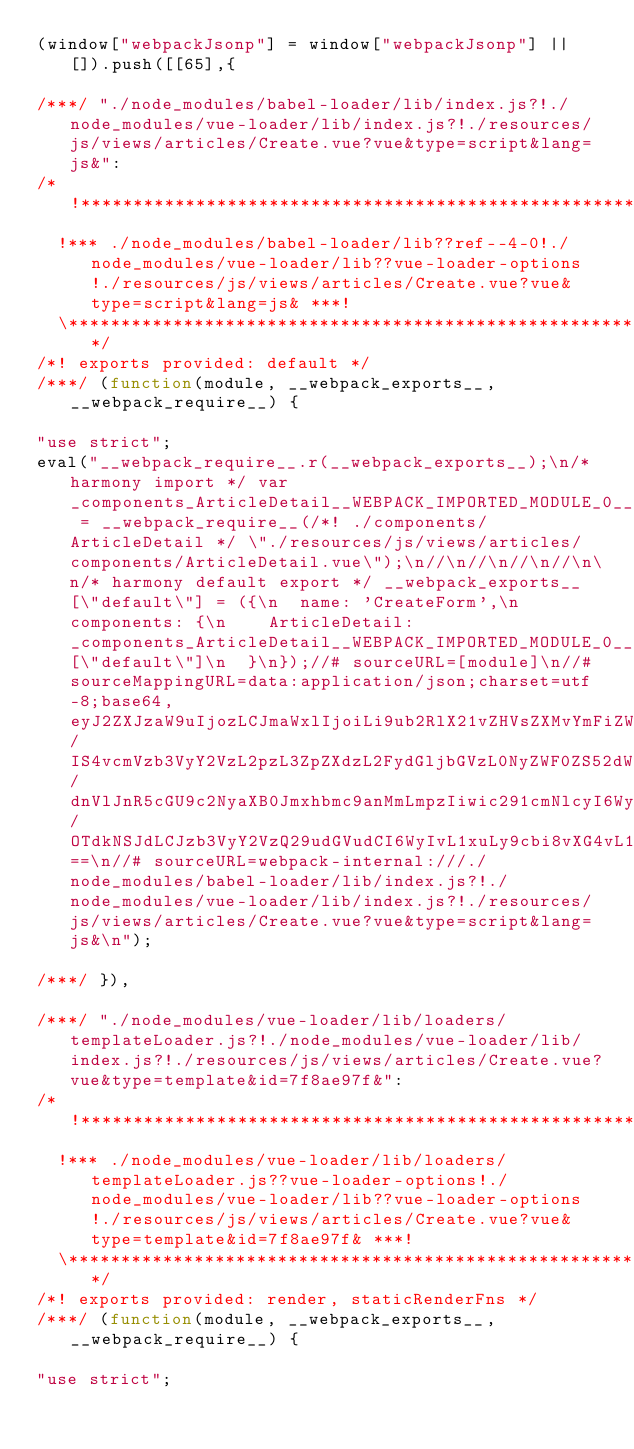Convert code to text. <code><loc_0><loc_0><loc_500><loc_500><_JavaScript_>(window["webpackJsonp"] = window["webpackJsonp"] || []).push([[65],{

/***/ "./node_modules/babel-loader/lib/index.js?!./node_modules/vue-loader/lib/index.js?!./resources/js/views/articles/Create.vue?vue&type=script&lang=js&":
/*!*********************************************************************************************************************************************************************!*\
  !*** ./node_modules/babel-loader/lib??ref--4-0!./node_modules/vue-loader/lib??vue-loader-options!./resources/js/views/articles/Create.vue?vue&type=script&lang=js& ***!
  \*********************************************************************************************************************************************************************/
/*! exports provided: default */
/***/ (function(module, __webpack_exports__, __webpack_require__) {

"use strict";
eval("__webpack_require__.r(__webpack_exports__);\n/* harmony import */ var _components_ArticleDetail__WEBPACK_IMPORTED_MODULE_0__ = __webpack_require__(/*! ./components/ArticleDetail */ \"./resources/js/views/articles/components/ArticleDetail.vue\");\n//\n//\n//\n//\n\n/* harmony default export */ __webpack_exports__[\"default\"] = ({\n  name: 'CreateForm',\n  components: {\n    ArticleDetail: _components_ArticleDetail__WEBPACK_IMPORTED_MODULE_0__[\"default\"]\n  }\n});//# sourceURL=[module]\n//# sourceMappingURL=data:application/json;charset=utf-8;base64,eyJ2ZXJzaW9uIjozLCJmaWxlIjoiLi9ub2RlX21vZHVsZXMvYmFiZWwtbG9hZGVyL2xpYi9pbmRleC5qcz8hLi9ub2RlX21vZHVsZXMvdnVlLWxvYWRlci9saWIvaW5kZXguanM/IS4vcmVzb3VyY2VzL2pzL3ZpZXdzL2FydGljbGVzL0NyZWF0ZS52dWU/dnVlJnR5cGU9c2NyaXB0Jmxhbmc9anMmLmpzIiwic291cmNlcyI6WyJ3ZWJwYWNrOi8vLy4vcmVzb3VyY2VzL2pzL3ZpZXdzL2FydGljbGVzL0NyZWF0ZS52dWU/OTdkNSJdLCJzb3VyY2VzQ29udGVudCI6WyIvL1xuLy9cbi8vXG4vL1xuaW1wb3J0IEFydGljbGVEZXRhaWwgZnJvbSAnLi9jb21wb25lbnRzL0FydGljbGVEZXRhaWwnO1xuZXhwb3J0IGRlZmF1bHQge1xuICBuYW1lOiAnQ3JlYXRlRm9ybScsXG4gIGNvbXBvbmVudHM6IHtcbiAgICBBcnRpY2xlRGV0YWlsOiBBcnRpY2xlRGV0YWlsXG4gIH1cbn07Il0sIm1hcHBpbmdzIjoiQUFBQTtBQUFBO0FBQUE7QUFDQTtBQUNBO0FBQ0E7QUFDQTtBQUNBO0FBQ0E7QUFDQTtBQUNBO0FBQ0E7QUFDQSIsInNvdXJjZVJvb3QiOiIifQ==\n//# sourceURL=webpack-internal:///./node_modules/babel-loader/lib/index.js?!./node_modules/vue-loader/lib/index.js?!./resources/js/views/articles/Create.vue?vue&type=script&lang=js&\n");

/***/ }),

/***/ "./node_modules/vue-loader/lib/loaders/templateLoader.js?!./node_modules/vue-loader/lib/index.js?!./resources/js/views/articles/Create.vue?vue&type=template&id=7f8ae97f&":
/*!*************************************************************************************************************************************************************************************************************!*\
  !*** ./node_modules/vue-loader/lib/loaders/templateLoader.js??vue-loader-options!./node_modules/vue-loader/lib??vue-loader-options!./resources/js/views/articles/Create.vue?vue&type=template&id=7f8ae97f& ***!
  \*************************************************************************************************************************************************************************************************************/
/*! exports provided: render, staticRenderFns */
/***/ (function(module, __webpack_exports__, __webpack_require__) {

"use strict";</code> 